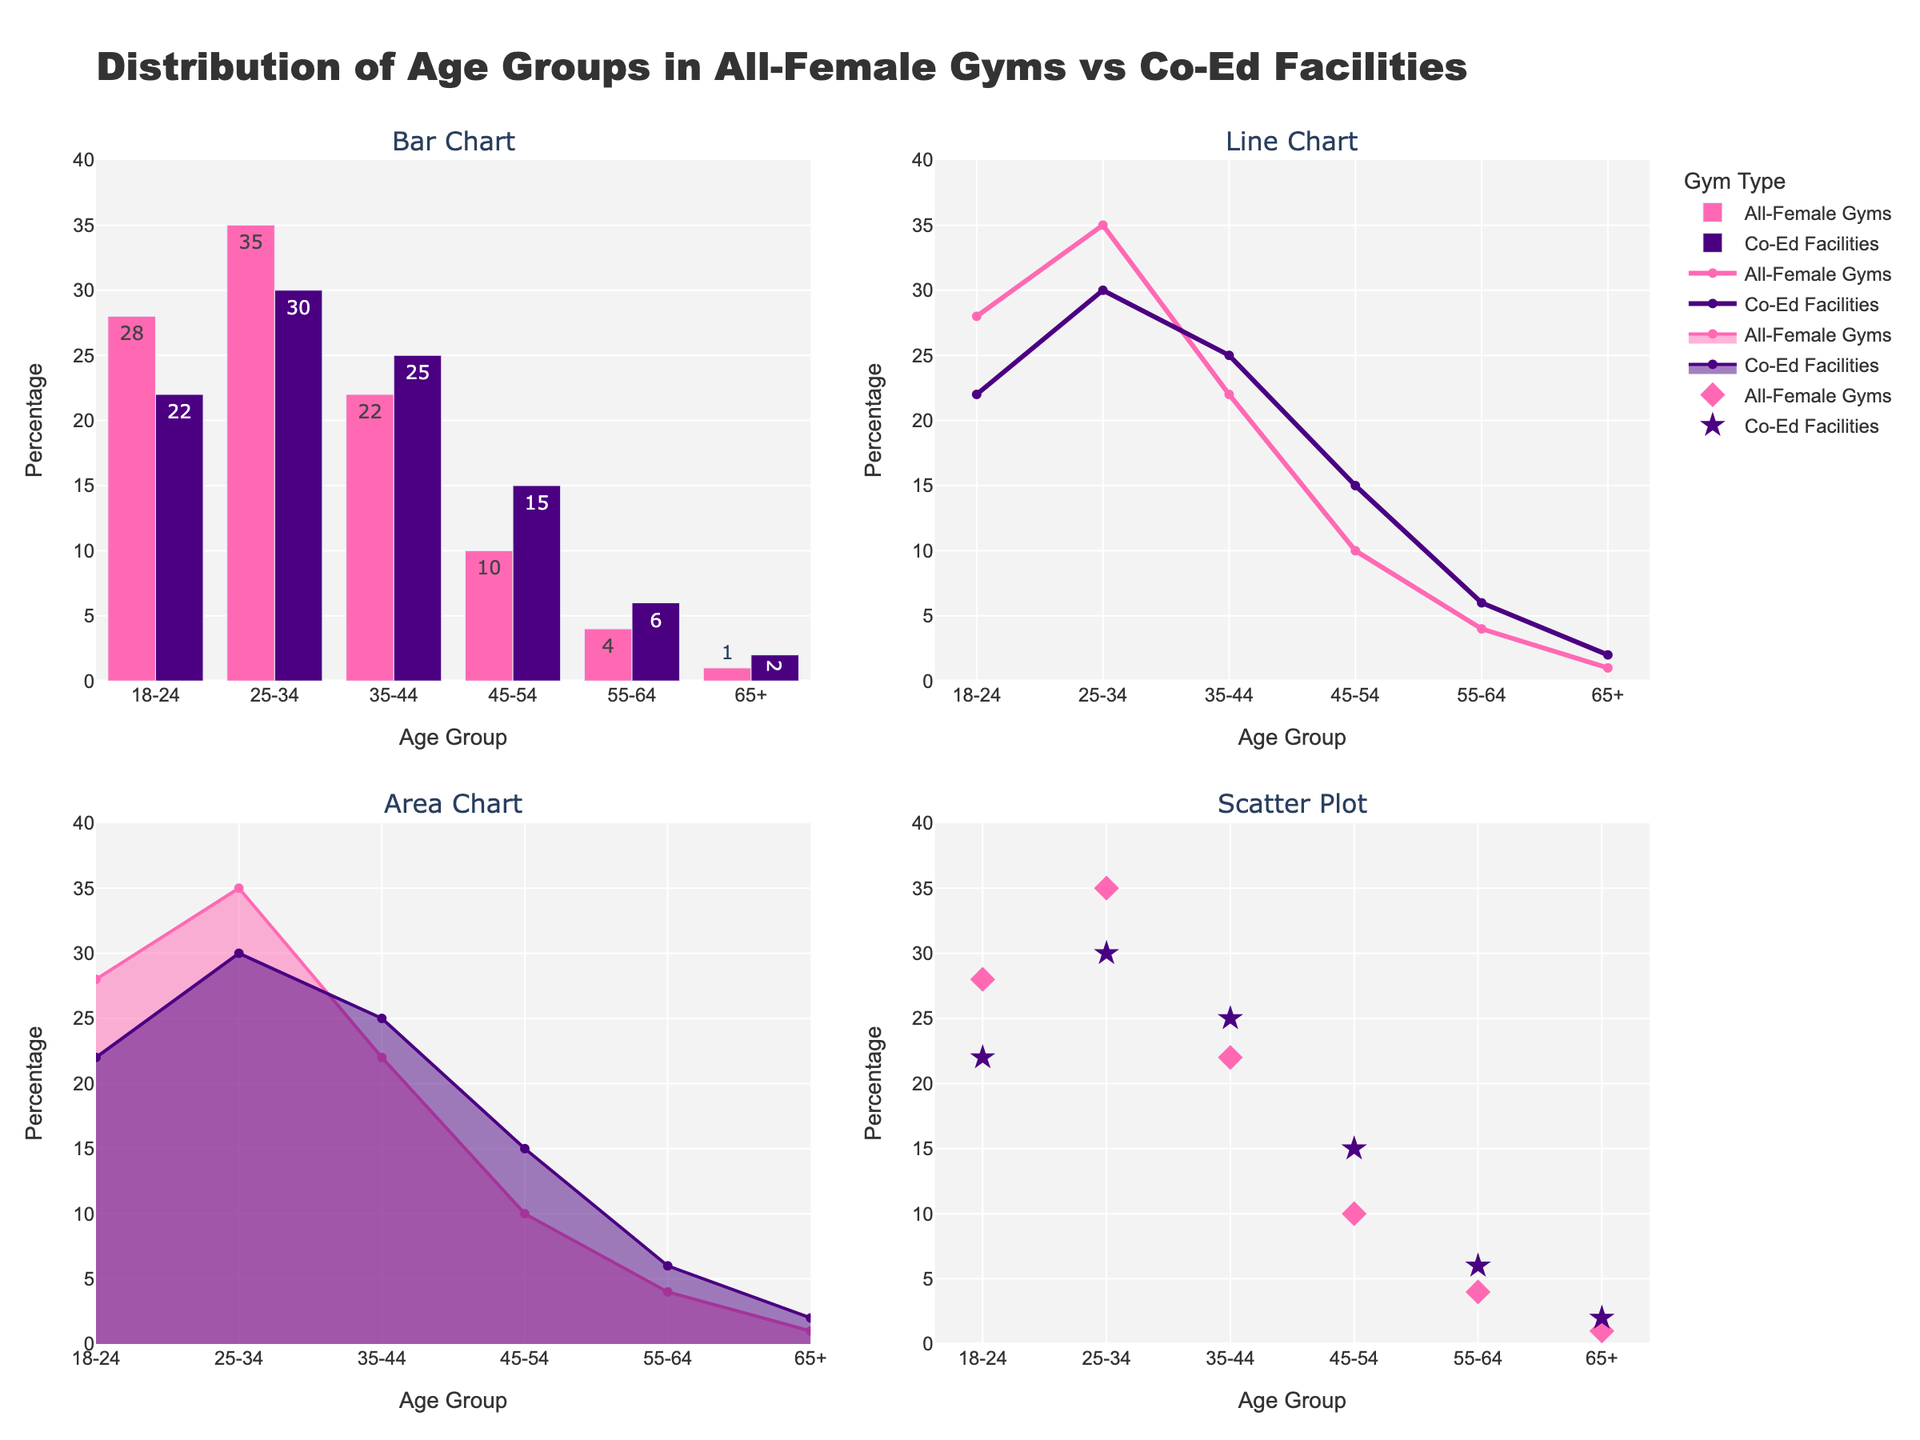Which region has the highest number of Ghost occurrences? By looking at the vertical bars in the bar chart, the tallest bar for Ghost occurrences is in North America.
Answer: North America How do UFO occurrences in South America compare to those in Australia in the line chart? The line chart shows that the line representing UFOs has a value of 35 in South America and 40 in Australia. Thus, Australia has a higher number of UFO occurrences than South America.
Answer: Australia has more Which region has the lowest number of Cryptid occurrences in the scatter plot? In the scatter plot, the region with the lowest Cryptid marker position along the y-axis is the Middle East with a value of 5.
Answer: Middle East What's the predominant supernatural phenomenon in the Caribbean as shown in the area chart? The area chart shows filled areas for different phenomena. In the Caribbean, the largest filled area is for Ghosts, indicating it's the predominant phenomenon.
Answer: Ghosts How many regions have more than 30 UFO occurrences, as visible in the bar chart? By counting the bars for UFOs in the bar chart that exceed the 30 mark on the y-axis, we see three regions: South America, Australia, and Pacific Islands.
Answer: Three regions Compare the trend lines for Ghosts and UFOs in Europe from the line chart. The line chart shows that both Ghost and UFO occurrences in Europe have a downward trend, but the Ghost line starts higher at 40 while the UFO line starts at 20.
Answer: Both have a downward trend, but Ghosts start higher What is the combined total of Cryptid occurrences in Asia and Africa as seen in the scatter plot? From the scatter plot, the values for Cryptids are 10 in Asia and 30 in Africa. Adding these together gives 40.
Answer: 40 Which phenomenon shows the greatest regional variance in occurrences in the bar chart? By comparing the heights of the bars for each phenomenon across regions, UFOs appear to have the largest variation, ranging from 10 in the Middle East to 40 in Australia.
Answer: UFOs What's the average number of Ghost occurrences across all regions based on the area chart? The area chart lists Ghost numbers per region. Summing these gives 45 + 40 + 35 + 30 + 25 + 20 + 15 + 35 + 30 + 25 = 300, and the average would be 300/10 = 30.
Answer: 30 In the line chart, what is the difference in Cryptid occurrences between Scandinavia and Pacific Islands? The line chart shows Cryptid values as 25 in Scandinavia and 10 in Pacific Islands. The difference is 25 - 10 = 15.
Answer: 15 